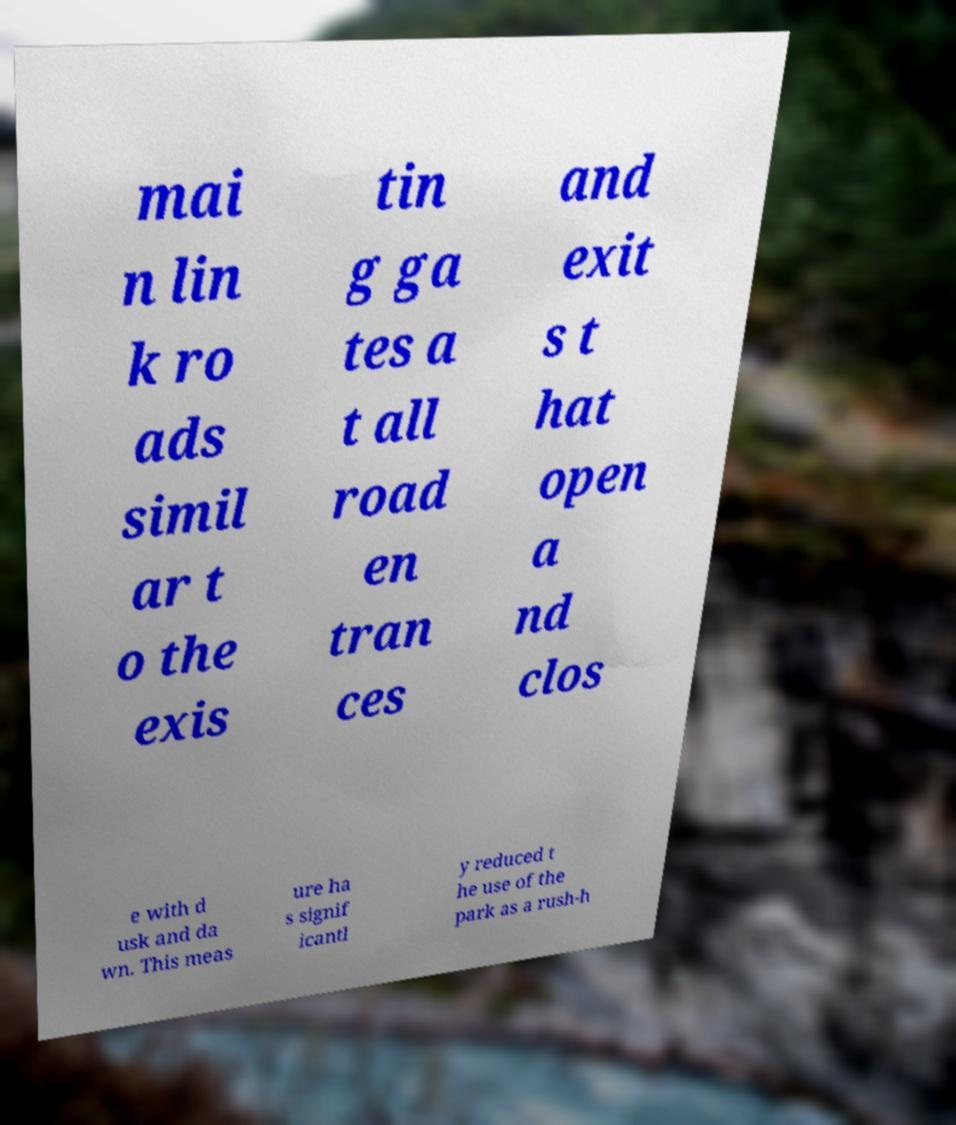Please read and relay the text visible in this image. What does it say? mai n lin k ro ads simil ar t o the exis tin g ga tes a t all road en tran ces and exit s t hat open a nd clos e with d usk and da wn. This meas ure ha s signif icantl y reduced t he use of the park as a rush-h 